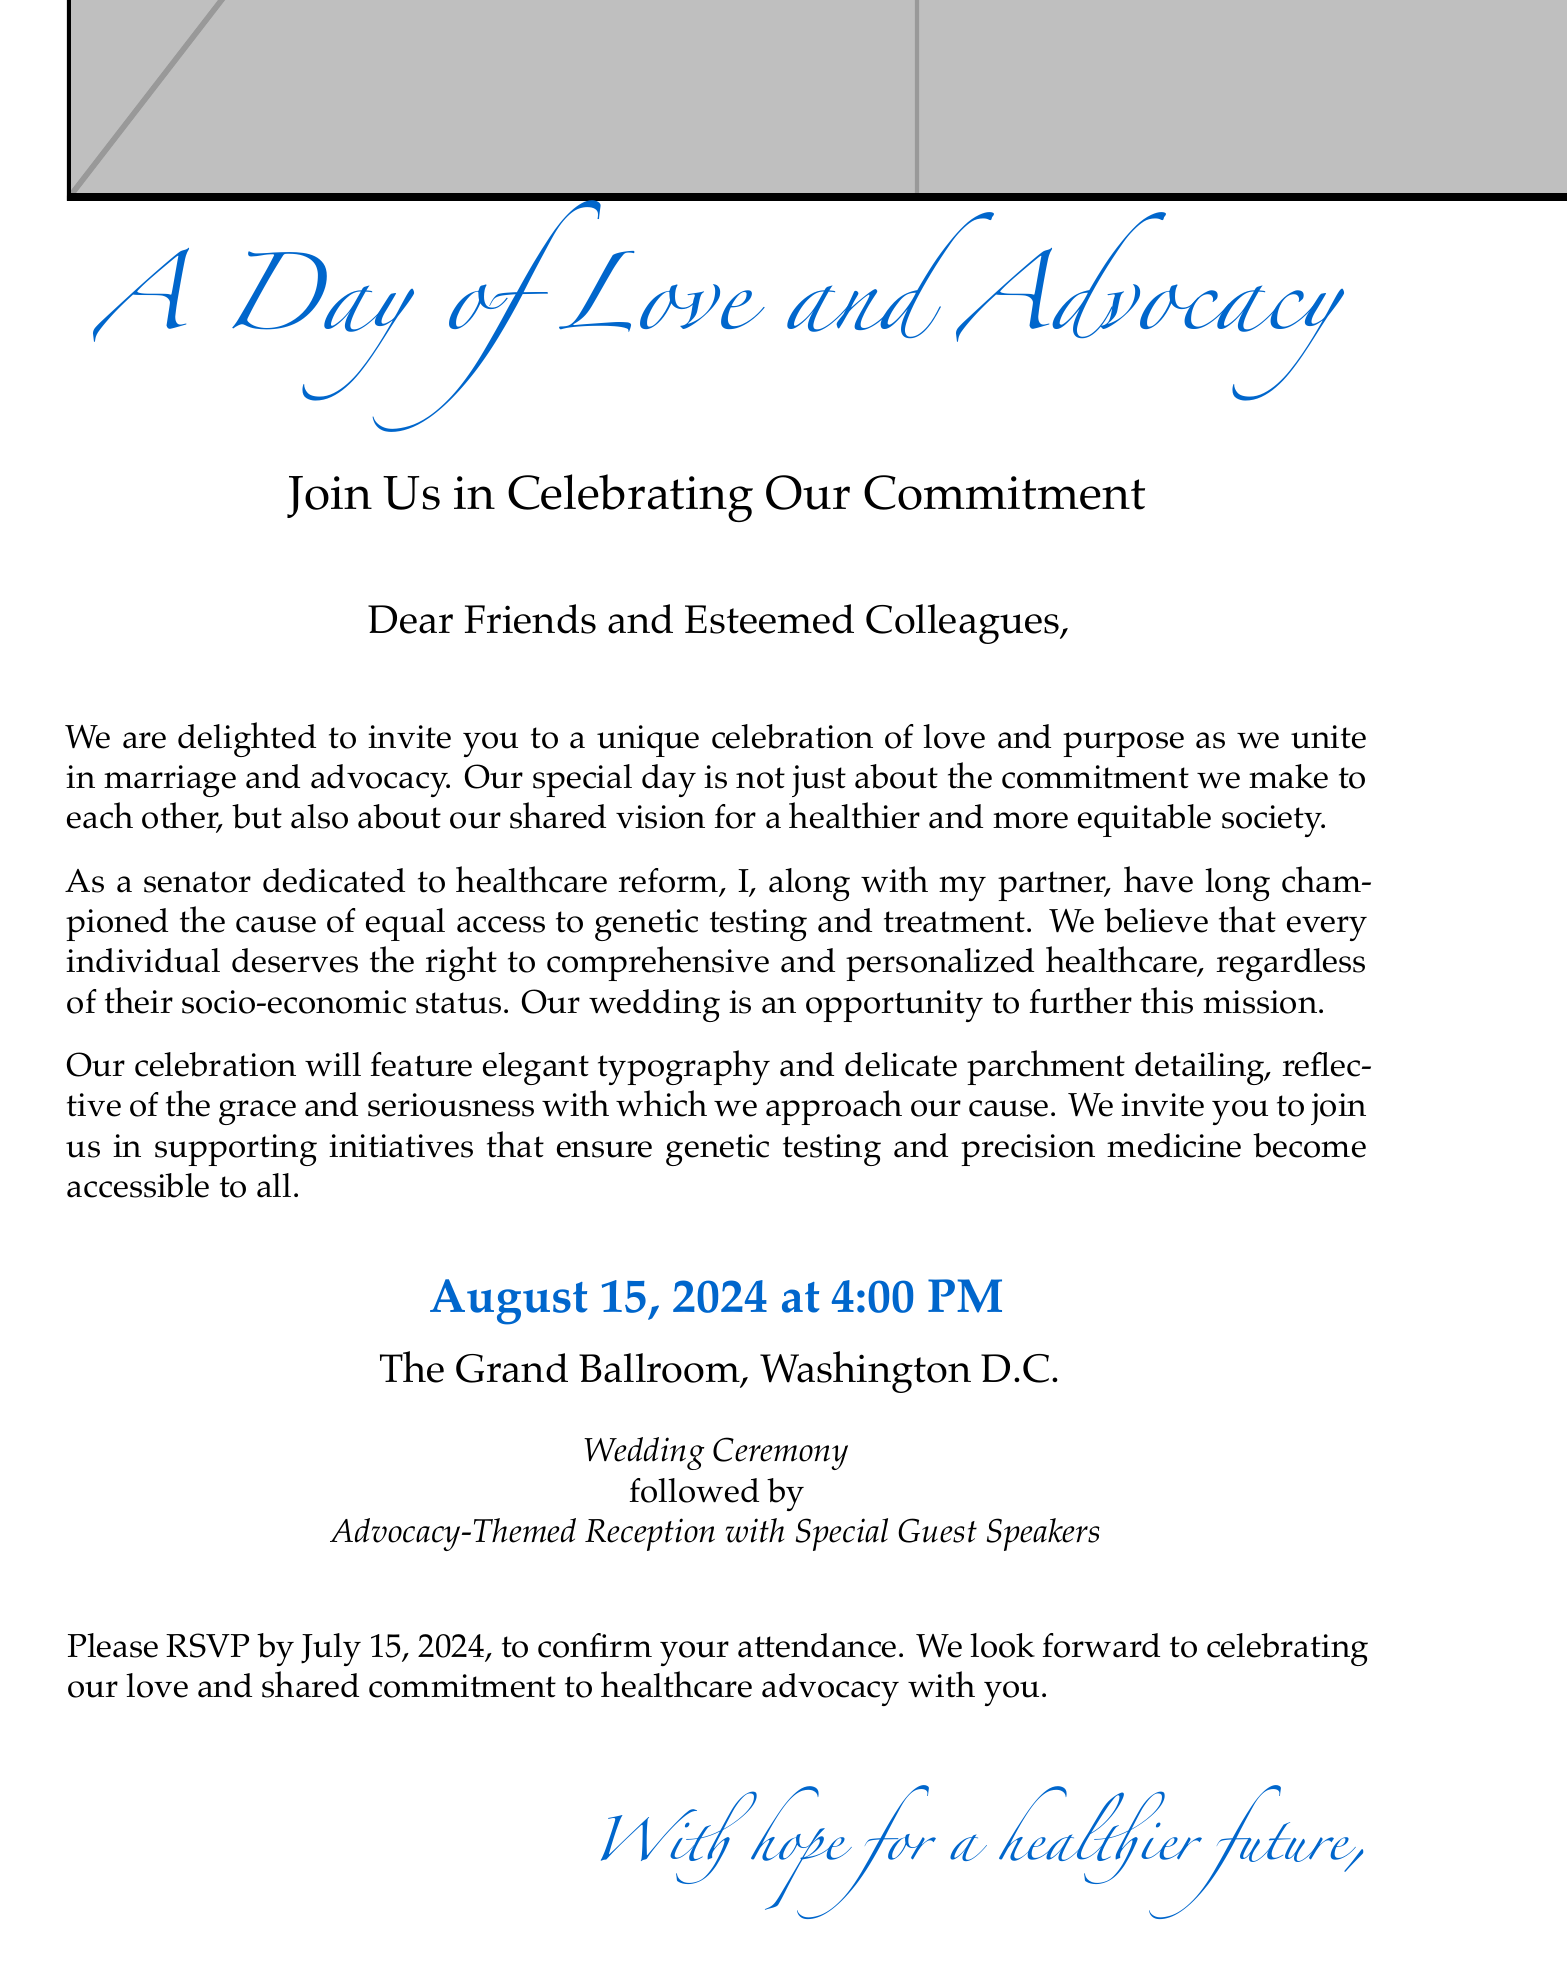What is the date of the wedding? The wedding date is explicitly mentioned in the invitation, which is August 15, 2024.
Answer: August 15, 2024 What time does the wedding ceremony begin? The start time for the wedding ceremony is provided in the invitation, which is at 4:00 PM.
Answer: 4:00 PM What location is specified for the celebration? The document states the location of the event as The Grand Ballroom, Washington D.C.
Answer: The Grand Ballroom, Washington D.C What is the RSVP deadline? The deadline for RSVP is clearly indicated in the document, which is July 15, 2024.
Answer: July 15, 2024 What key cause is highlighted in the invitation? The invitation emphasizes the couple's advocacy for equal access to genetic testing and treatment.
Answer: Equal access to genetic testing and treatment What type of event follows the wedding ceremony? The document mentions that there will be an advocacy-themed reception after the wedding ceremony.
Answer: Advocacy-Themed Reception What kind of typography is used in the invitation? The invitation describes the typography as elegant, which reflects the overall design theme of the document.
Answer: Elegant typography Who is invited to the wedding? The invitation addresses the guests as "Dear Friends and Esteemed Colleagues," indicating the intended audience.
Answer: Friends and Esteemed Colleagues 